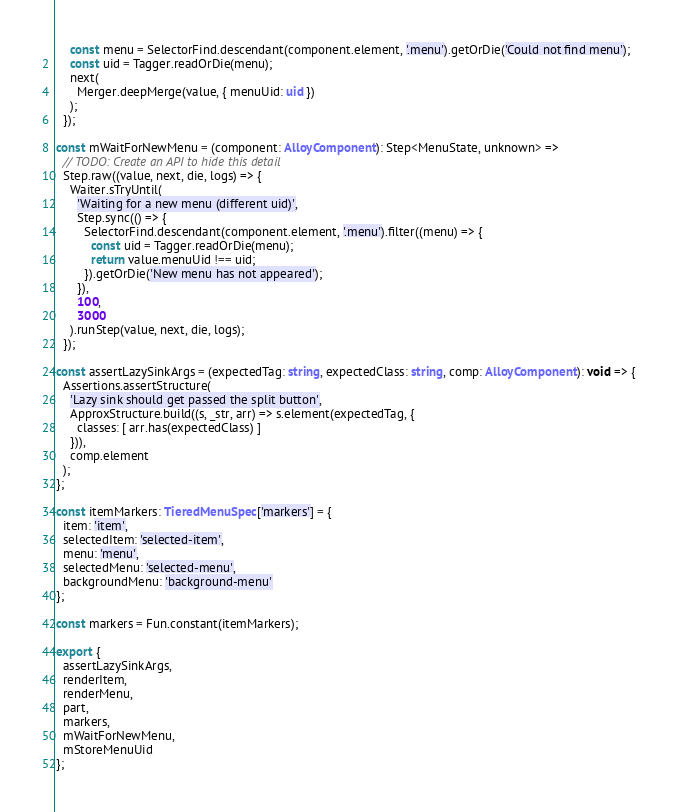Convert code to text. <code><loc_0><loc_0><loc_500><loc_500><_TypeScript_>    const menu = SelectorFind.descendant(component.element, '.menu').getOrDie('Could not find menu');
    const uid = Tagger.readOrDie(menu);
    next(
      Merger.deepMerge(value, { menuUid: uid })
    );
  });

const mWaitForNewMenu = (component: AlloyComponent): Step<MenuState, unknown> =>
  // TODO: Create an API to hide this detail
  Step.raw((value, next, die, logs) => {
    Waiter.sTryUntil(
      'Waiting for a new menu (different uid)',
      Step.sync(() => {
        SelectorFind.descendant(component.element, '.menu').filter((menu) => {
          const uid = Tagger.readOrDie(menu);
          return value.menuUid !== uid;
        }).getOrDie('New menu has not appeared');
      }),
      100,
      3000
    ).runStep(value, next, die, logs);
  });

const assertLazySinkArgs = (expectedTag: string, expectedClass: string, comp: AlloyComponent): void => {
  Assertions.assertStructure(
    'Lazy sink should get passed the split button',
    ApproxStructure.build((s, _str, arr) => s.element(expectedTag, {
      classes: [ arr.has(expectedClass) ]
    })),
    comp.element
  );
};

const itemMarkers: TieredMenuSpec['markers'] = {
  item: 'item',
  selectedItem: 'selected-item',
  menu: 'menu',
  selectedMenu: 'selected-menu',
  backgroundMenu: 'background-menu'
};

const markers = Fun.constant(itemMarkers);

export {
  assertLazySinkArgs,
  renderItem,
  renderMenu,
  part,
  markers,
  mWaitForNewMenu,
  mStoreMenuUid
};
</code> 